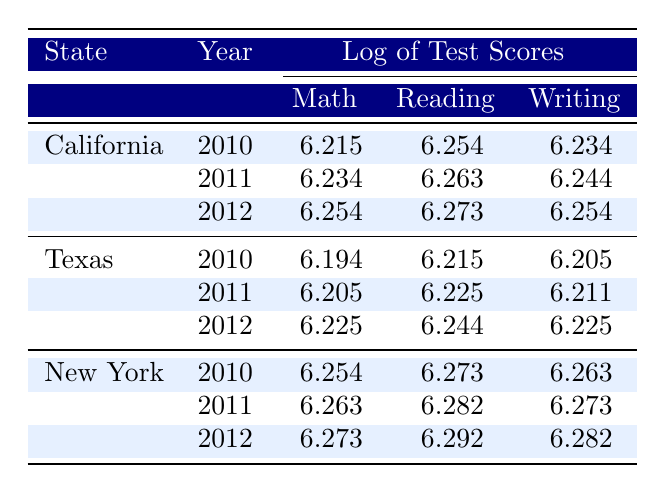What was the math score for California in 2011? The table lists the math score for California in 2011 as 6.234.
Answer: 6.234 What was the writing score for Texas in 2012? The table shows that the writing score for Texas in 2012 is 6.225.
Answer: 6.225 Is the math score for New York in 2010 higher than the math score for Texas in 2010? The math score for New York in 2010 is 6.254, whereas Texas's score is 6.194. Since 6.254 is greater than 6.194, the statement is true.
Answer: Yes What is the average reading score for California over the years presented? The reading scores for California are 6.254 (2010), 6.263 (2011), and 6.273 (2012). Adding these gives 6.254 + 6.263 + 6.273 = 18.790. Dividing by 3 gives an average of 18.790 / 3 = 6.263.
Answer: 6.263 Does Texas have a higher mean test score than California across all subjects in 2012? The mean scores for 2012 are California: (6.254 + 6.273 + 6.254) / 3 = 6.260; Texas: (6.225 + 6.244 + 6.225) / 3 = 6.231. Since 6.260 > 6.231, Texas does not have a higher mean score than California.
Answer: No What is the difference in the writing score between New York and California in 2011? The writing score for New York in 2011 is 6.273 and for California it is 6.244. The difference is 6.273 - 6.244 = 0.029.
Answer: 0.029 What is the lowest reading score recorded in the table? Looking through the reading scores, the lowest value for math in the provided data is Texas's score in 2010, which is 6.215.
Answer: 6.215 Did New York's writing scores consistently increase from 2010 to 2012? The writing scores for New York are 6.263 (2010), 6.273 (2011), and 6.282 (2012). Since 6.263 < 6.273 < 6.282, the writing scores increased consistently.
Answer: Yes 